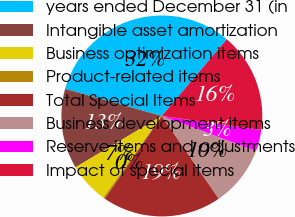<chart> <loc_0><loc_0><loc_500><loc_500><pie_chart><fcel>years ended December 31 (in<fcel>Intangible asset amortization<fcel>Business optimization items<fcel>Product-related items<fcel>Total Special Items<fcel>Business development items<fcel>Reserve items and adjustments<fcel>Impact of special items<nl><fcel>31.83%<fcel>12.89%<fcel>6.58%<fcel>0.27%<fcel>19.21%<fcel>9.74%<fcel>3.43%<fcel>16.05%<nl></chart> 